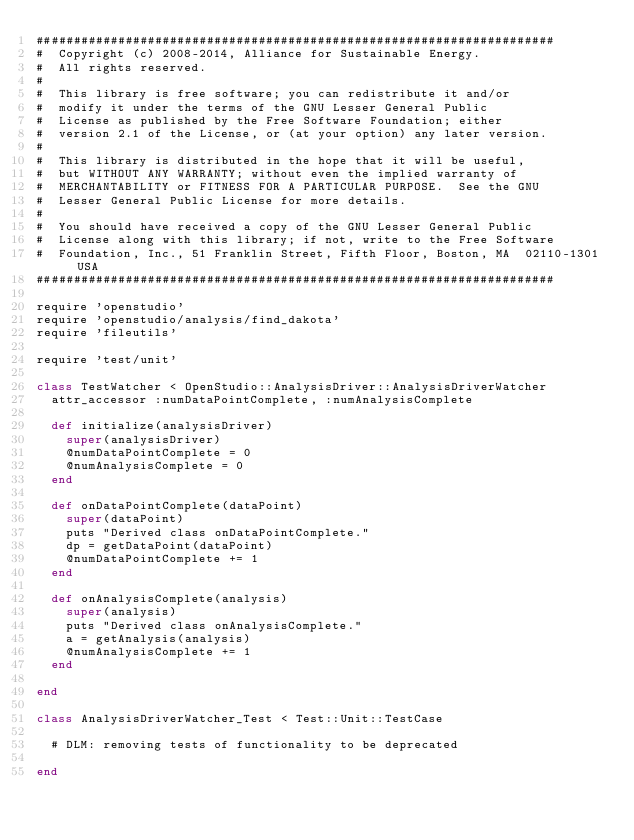<code> <loc_0><loc_0><loc_500><loc_500><_Ruby_>######################################################################
#  Copyright (c) 2008-2014, Alliance for Sustainable Energy.  
#  All rights reserved.
#  
#  This library is free software; you can redistribute it and/or
#  modify it under the terms of the GNU Lesser General Public
#  License as published by the Free Software Foundation; either
#  version 2.1 of the License, or (at your option) any later version.
#  
#  This library is distributed in the hope that it will be useful,
#  but WITHOUT ANY WARRANTY; without even the implied warranty of
#  MERCHANTABILITY or FITNESS FOR A PARTICULAR PURPOSE.  See the GNU
#  Lesser General Public License for more details.
#  
#  You should have received a copy of the GNU Lesser General Public
#  License along with this library; if not, write to the Free Software
#  Foundation, Inc., 51 Franklin Street, Fifth Floor, Boston, MA  02110-1301  USA
######################################################################

require 'openstudio'
require 'openstudio/analysis/find_dakota'
require 'fileutils'

require 'test/unit'

class TestWatcher < OpenStudio::AnalysisDriver::AnalysisDriverWatcher
  attr_accessor :numDataPointComplete, :numAnalysisComplete

  def initialize(analysisDriver)
    super(analysisDriver)
    @numDataPointComplete = 0
    @numAnalysisComplete = 0
  end
  
  def onDataPointComplete(dataPoint)
    super(dataPoint)
    puts "Derived class onDataPointComplete."
    dp = getDataPoint(dataPoint)
    @numDataPointComplete += 1
  end  
  
  def onAnalysisComplete(analysis)
    super(analysis)
    puts "Derived class onAnalysisComplete."    
    a = getAnalysis(analysis)
    @numAnalysisComplete += 1
  end
  
end

class AnalysisDriverWatcher_Test < Test::Unit::TestCase
  
  # DLM: removing tests of functionality to be deprecated
  
end

</code> 